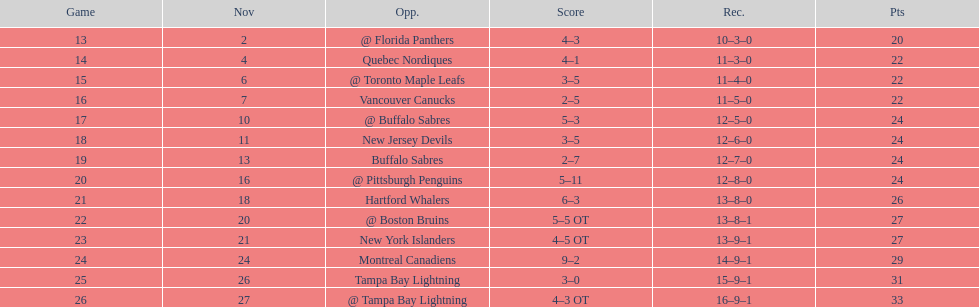What other team had the closest amount of wins? New York Islanders. 